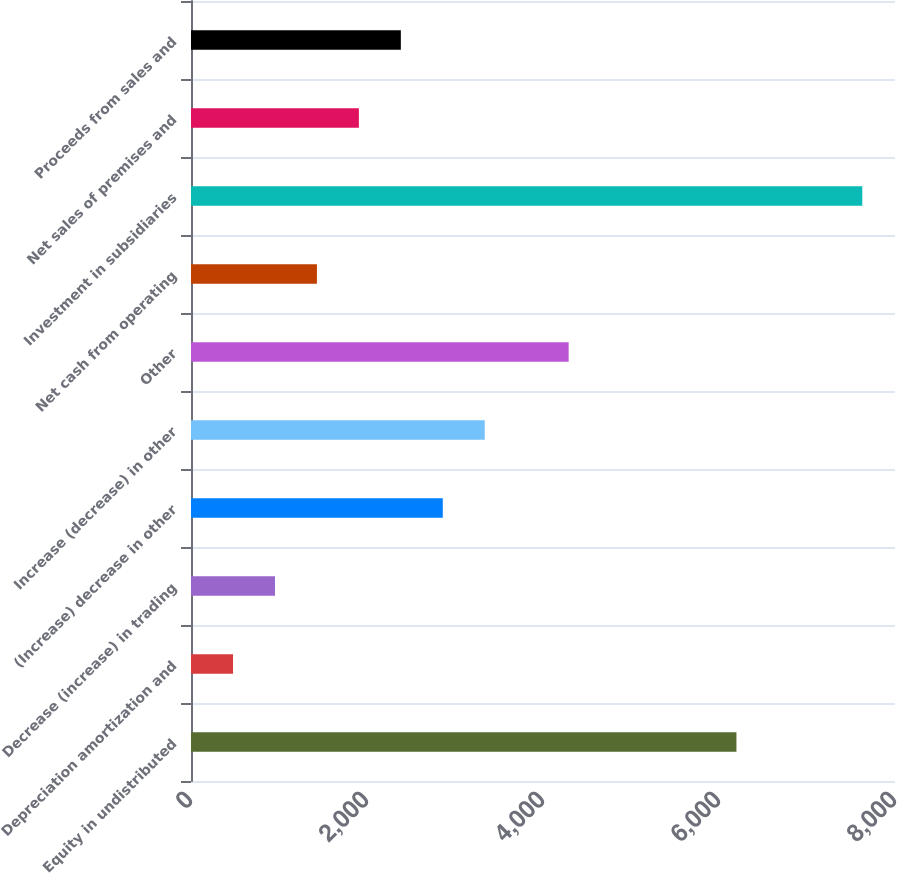Convert chart to OTSL. <chart><loc_0><loc_0><loc_500><loc_500><bar_chart><fcel>Equity in undistributed<fcel>Depreciation amortization and<fcel>Decrease (increase) in trading<fcel>(Increase) decrease in other<fcel>Increase (decrease) in other<fcel>Other<fcel>Net cash from operating<fcel>Investment in subsidiaries<fcel>Net sales of premises and<fcel>Proceeds from sales and<nl><fcel>6198.1<fcel>477.7<fcel>954.4<fcel>2861.2<fcel>3337.9<fcel>4291.3<fcel>1431.1<fcel>7628.2<fcel>1907.8<fcel>2384.5<nl></chart> 